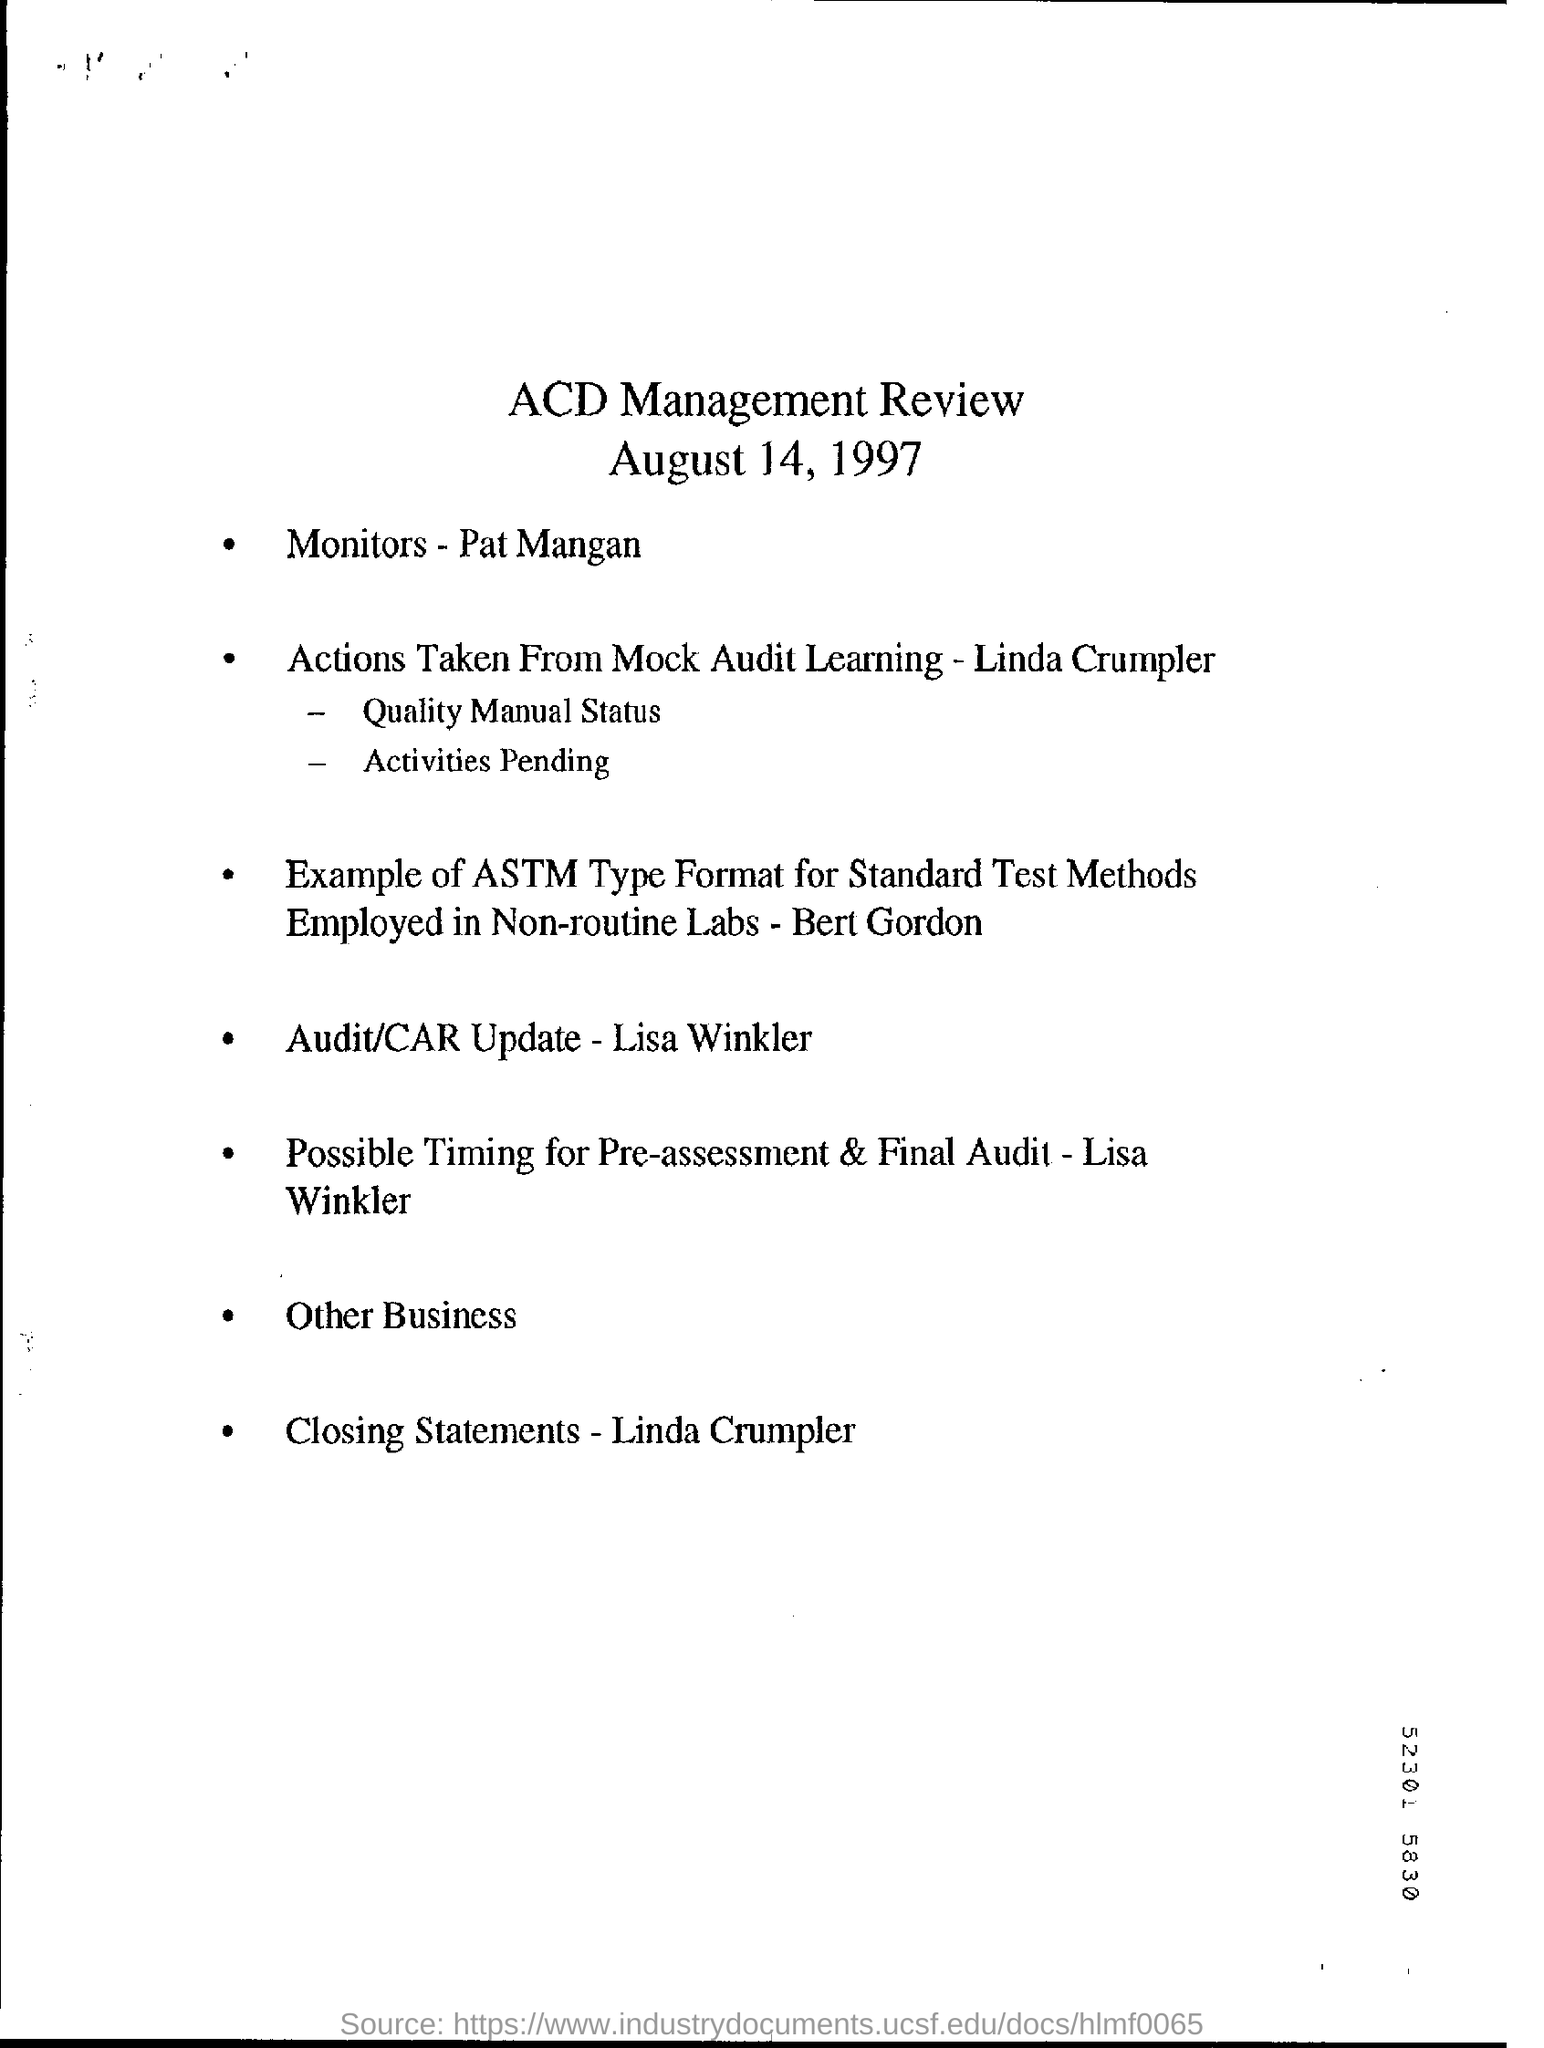Indicate a few pertinent items in this graphic. The title of the document is "ACD Management Review. The date on the document is August 14, 1997. 